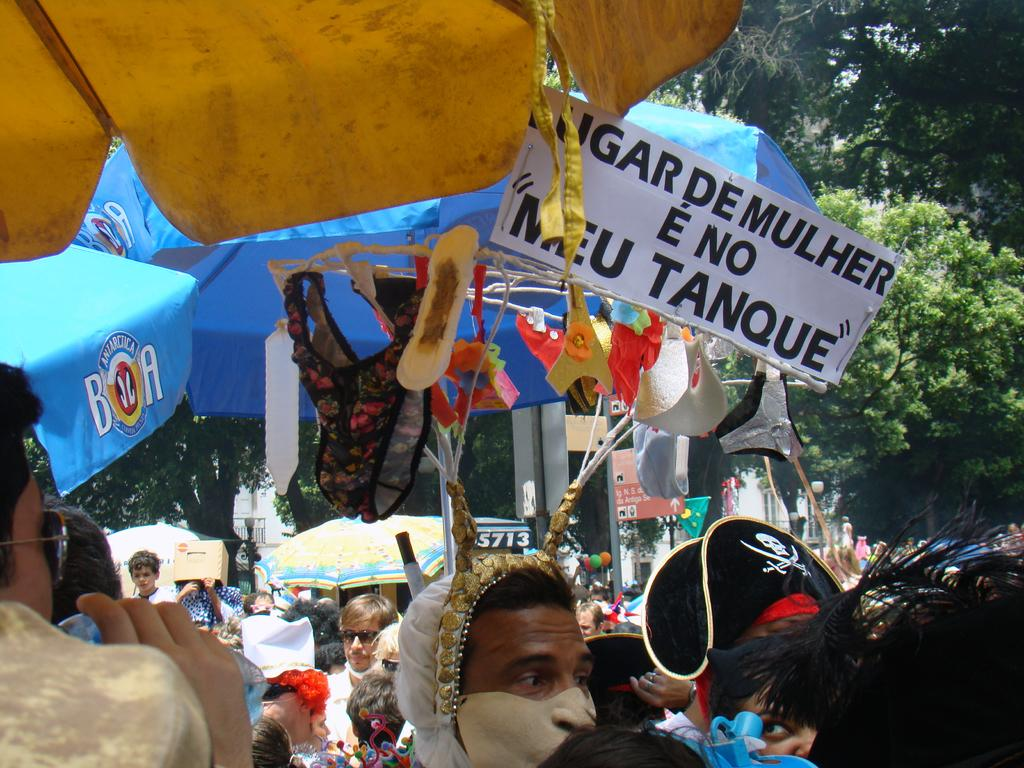How many people are in the image? There is a group of people in the image, but the exact number cannot be determined from the provided facts. What are the people holding in the image? Umbrellas are present in the image, and it is possible that some people might be holding them. What can be used to identify specific locations or individuals in the image? Name boards are visible in the image, which can be used for identification purposes. What is the symbolic object in the image? There is a flag in the image, which might represent a country, organization, or event. What are the colorful objects in the image? Balloons are present in the image, which are typically used for decoration or celebration. What other objects can be seen in the image? There are objects in the image, but their specific nature cannot be determined from the provided facts. What can be seen in the background of the image? Trees are visible in the background of the image, indicating a natural setting. How many oranges are being used for payment in the image? There is no mention of oranges or payment in the image, so this question cannot be answered definitively. 